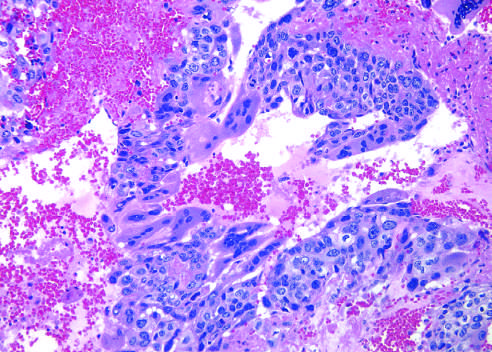re healthy neutrophils with nuclei present?
Answer the question using a single word or phrase. No 